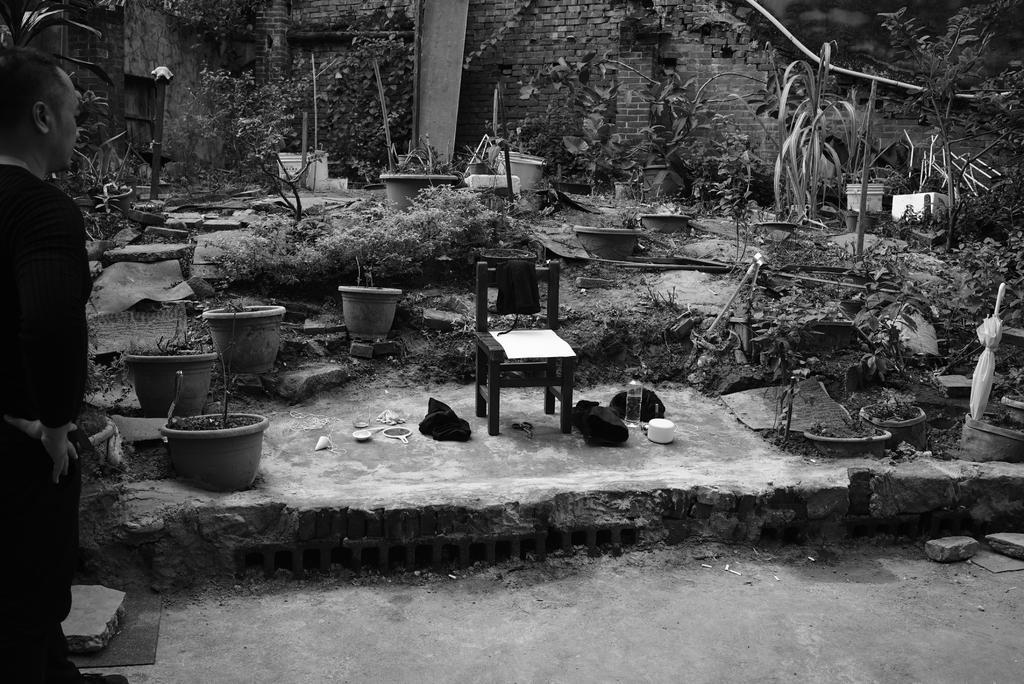Can you describe this image briefly? This is a black and white image. In this image I can see a chair, many pots, plants, bottle, clothes and many other objects on the ground. It seems to be a garden. In the background there are many plants and trees and also I can see the wall. On the left side there is a person standing facing towards the back side. 